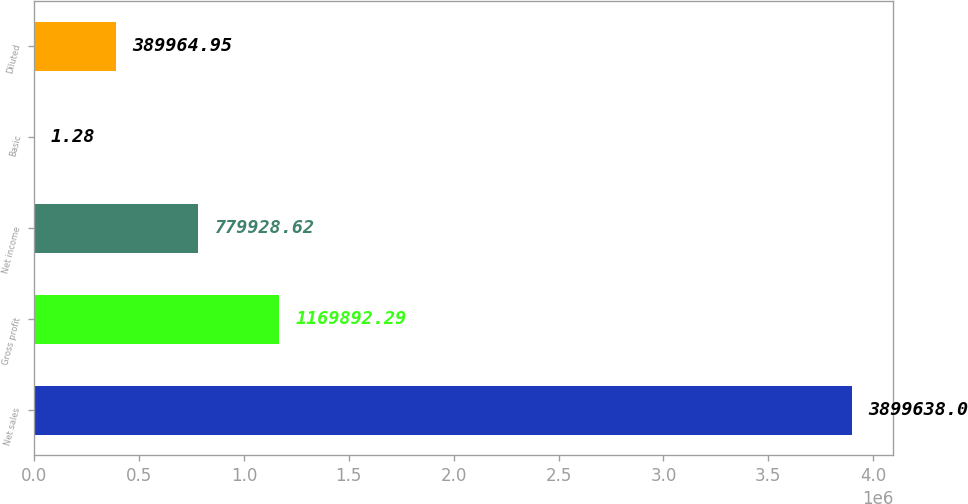Convert chart to OTSL. <chart><loc_0><loc_0><loc_500><loc_500><bar_chart><fcel>Net sales<fcel>Gross profit<fcel>Net income<fcel>Basic<fcel>Diluted<nl><fcel>3.89964e+06<fcel>1.16989e+06<fcel>779929<fcel>1.28<fcel>389965<nl></chart> 